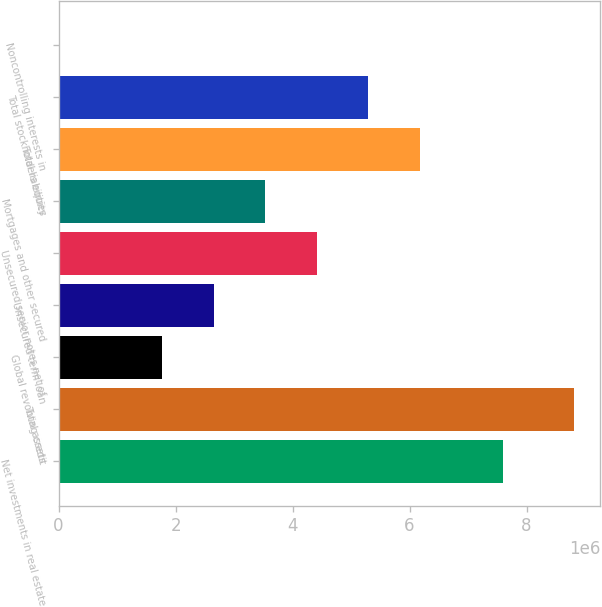Convert chart to OTSL. <chart><loc_0><loc_0><loc_500><loc_500><bar_chart><fcel>Net investments in real estate<fcel>Total assets<fcel>Global revolving credit<fcel>Unsecured term loan<fcel>Unsecured senior notes net of<fcel>Mortgages and other secured<fcel>Total liabilities<fcel>Total stockholders equity<fcel>Noncontrolling interests in<nl><fcel>7.60314e+06<fcel>8.81921e+06<fcel>1.7686e+06<fcel>2.64992e+06<fcel>4.41258e+06<fcel>3.53125e+06<fcel>6.17523e+06<fcel>5.29391e+06<fcel>5944<nl></chart> 